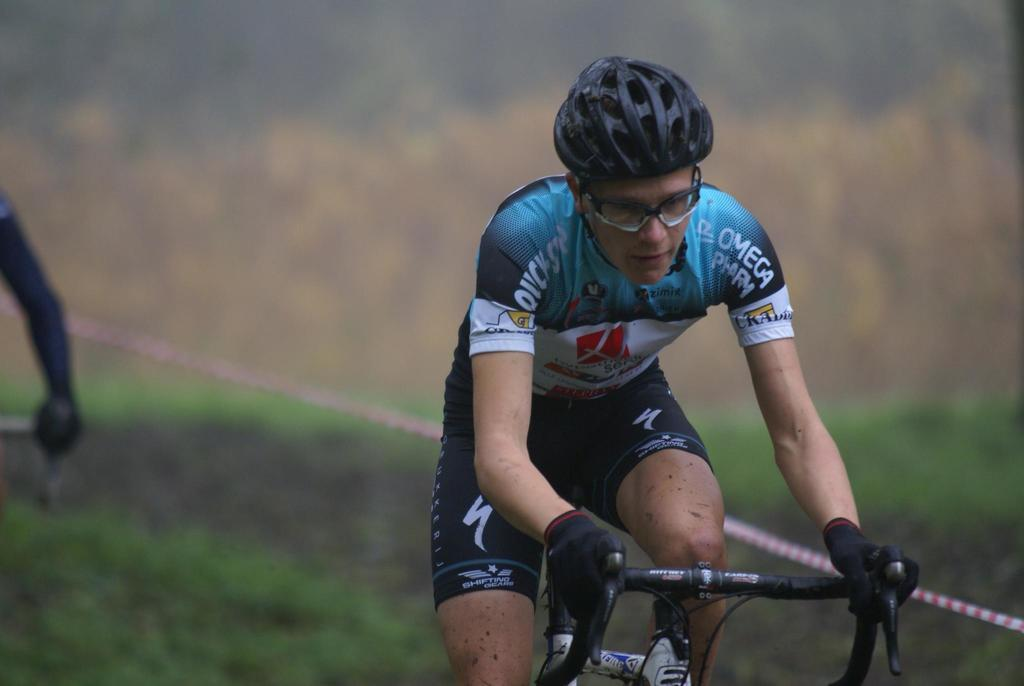What is the main subject of the image? There is a person in the image. What is the person doing in the image? The person is riding a bicycle. What is the person wearing in the image? The person is wearing clothes and a helmet. Can you describe the background of the image? The background of the image is blurred. What type of cherry is the person holding in the image? There is no cherry present in the image. Are there any bears visible in the background of the image? There are no bears visible in the image; the background is blurred. 